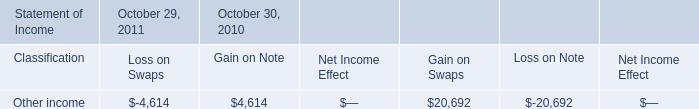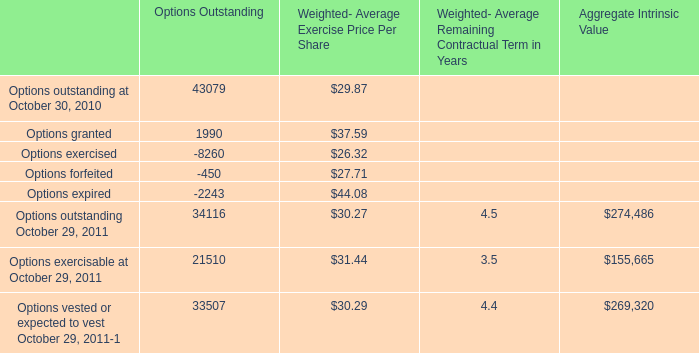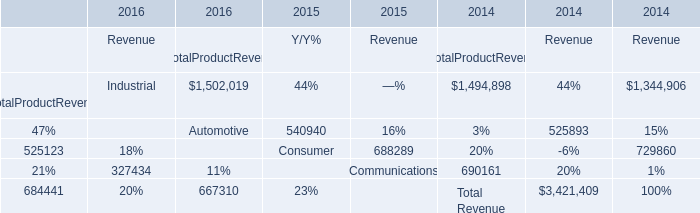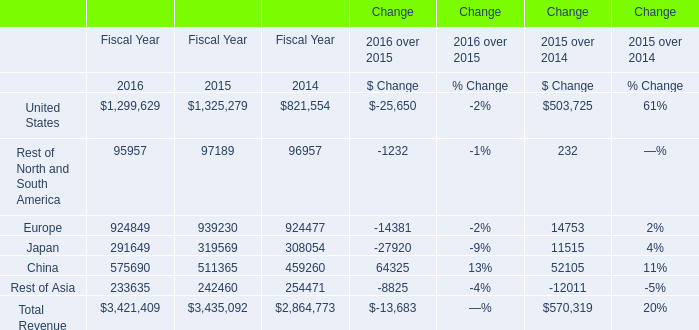In the year with largest amount of Total Revenue, what's the increasing rate of Rest of Asia? 
Computations: ((233635 - 242460) / 242460)
Answer: -0.0364. 